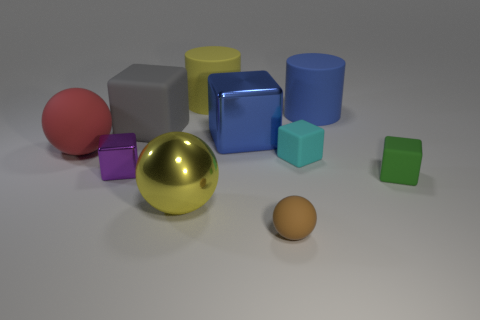Is the gray thing made of the same material as the red ball?
Your answer should be compact. Yes. Is there anything else that is the same shape as the big gray rubber object?
Ensure brevity in your answer.  Yes. There is a large cube that is on the right side of the large matte cylinder that is on the left side of the brown ball; what is its material?
Offer a terse response. Metal. There is a yellow object in front of the gray matte block; what size is it?
Your answer should be very brief. Large. What color is the large thing that is right of the big shiny sphere and in front of the blue cylinder?
Your answer should be compact. Blue. There is a matte ball left of the brown matte ball; is its size the same as the cyan cube?
Provide a succinct answer. No. There is a yellow object that is behind the red matte thing; are there any large rubber things in front of it?
Your answer should be very brief. Yes. What is the small cyan object made of?
Offer a terse response. Rubber. Are there any metallic cubes left of the yellow metal ball?
Provide a short and direct response. Yes. There is a green matte thing that is the same shape as the tiny purple thing; what is its size?
Your answer should be compact. Small. 